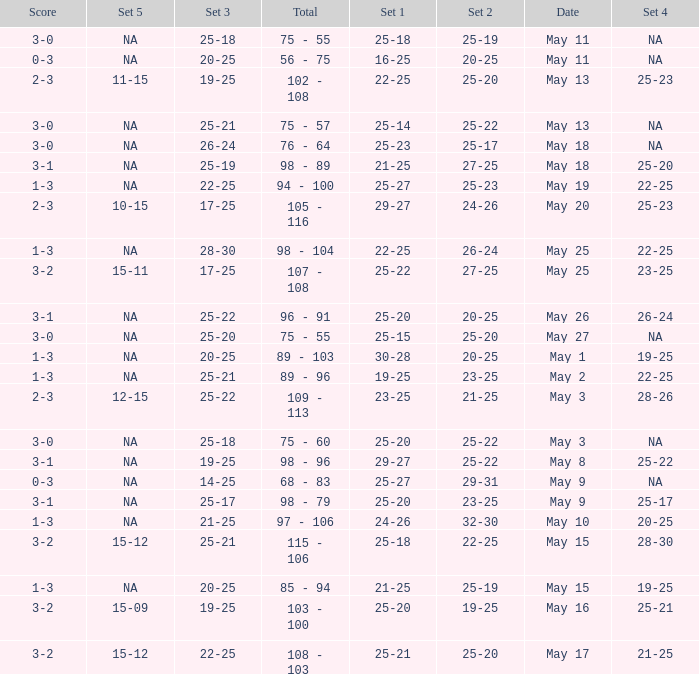What is the set 2 the has 1 set of 21-25, and 4 sets of 25-20? 27-25. 